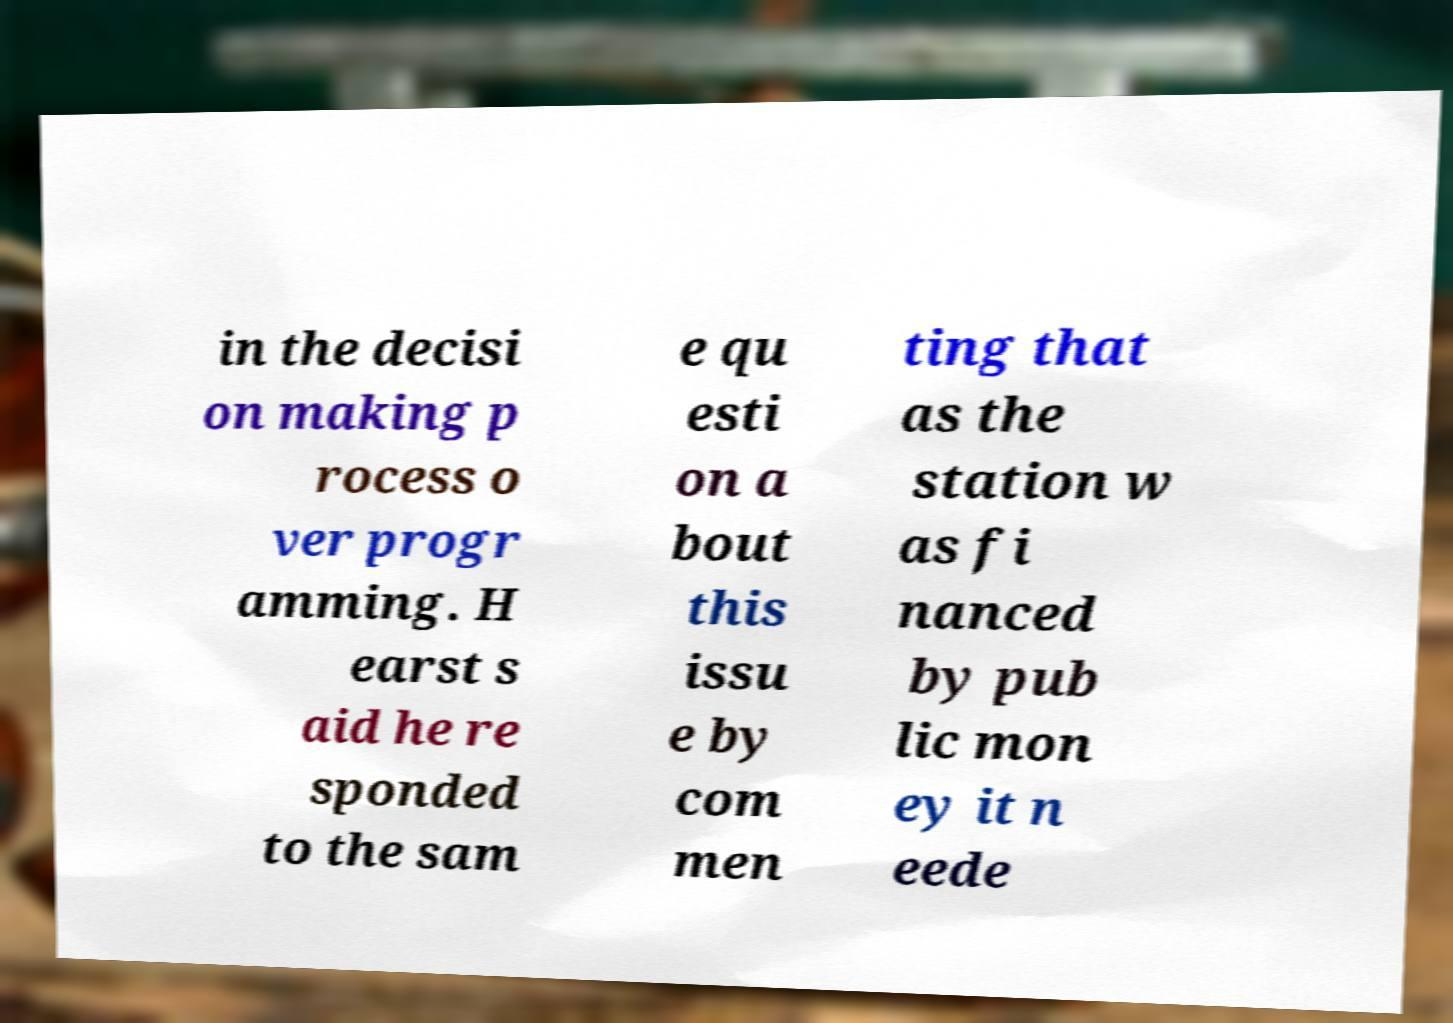Please identify and transcribe the text found in this image. in the decisi on making p rocess o ver progr amming. H earst s aid he re sponded to the sam e qu esti on a bout this issu e by com men ting that as the station w as fi nanced by pub lic mon ey it n eede 